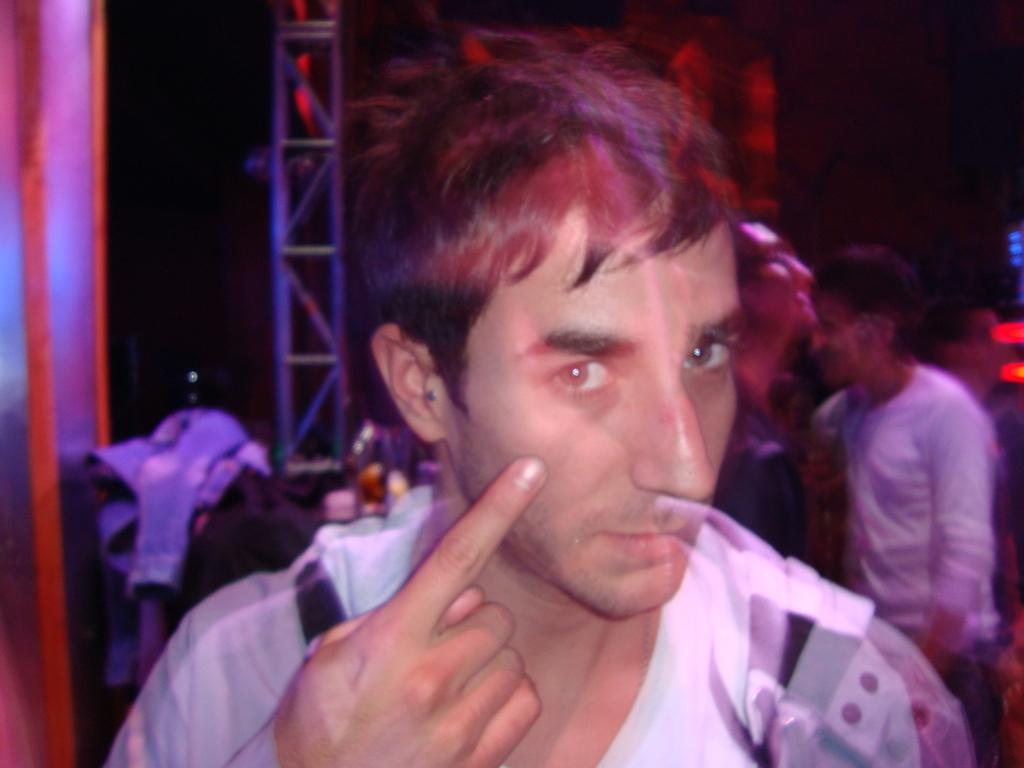Describe this image in one or two sentences. In this image I can see a person standing wearing black shirt. Background I can see few other persons standing and a railing. 